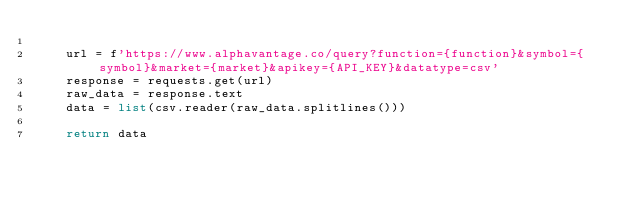Convert code to text. <code><loc_0><loc_0><loc_500><loc_500><_Python_>
    url = f'https://www.alphavantage.co/query?function={function}&symbol={symbol}&market={market}&apikey={API_KEY}&datatype=csv'
    response = requests.get(url)
    raw_data = response.text
    data = list(csv.reader(raw_data.splitlines()))

    return data
</code> 